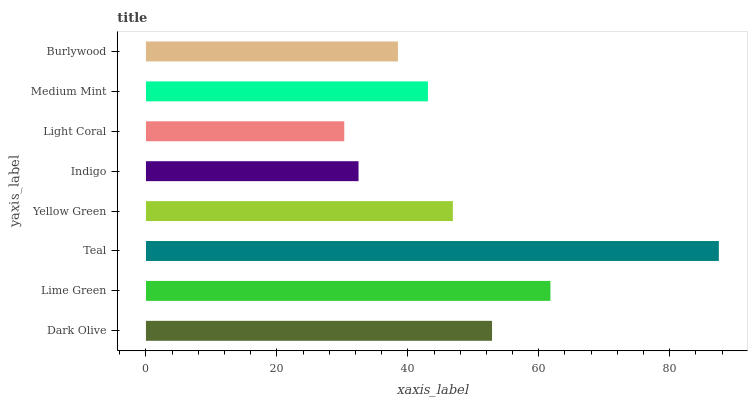Is Light Coral the minimum?
Answer yes or no. Yes. Is Teal the maximum?
Answer yes or no. Yes. Is Lime Green the minimum?
Answer yes or no. No. Is Lime Green the maximum?
Answer yes or no. No. Is Lime Green greater than Dark Olive?
Answer yes or no. Yes. Is Dark Olive less than Lime Green?
Answer yes or no. Yes. Is Dark Olive greater than Lime Green?
Answer yes or no. No. Is Lime Green less than Dark Olive?
Answer yes or no. No. Is Yellow Green the high median?
Answer yes or no. Yes. Is Medium Mint the low median?
Answer yes or no. Yes. Is Burlywood the high median?
Answer yes or no. No. Is Indigo the low median?
Answer yes or no. No. 